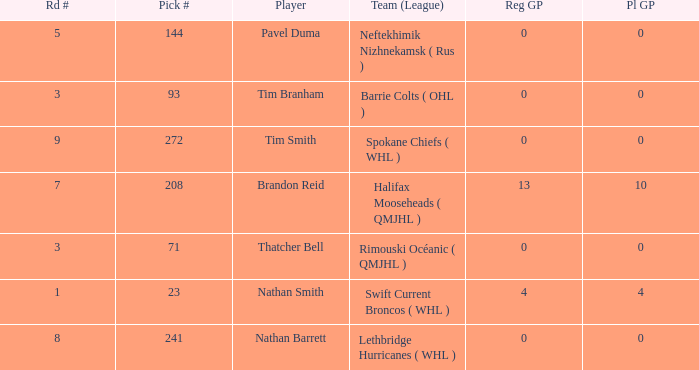How many reg GP for nathan barrett in a round less than 8? 0.0. 